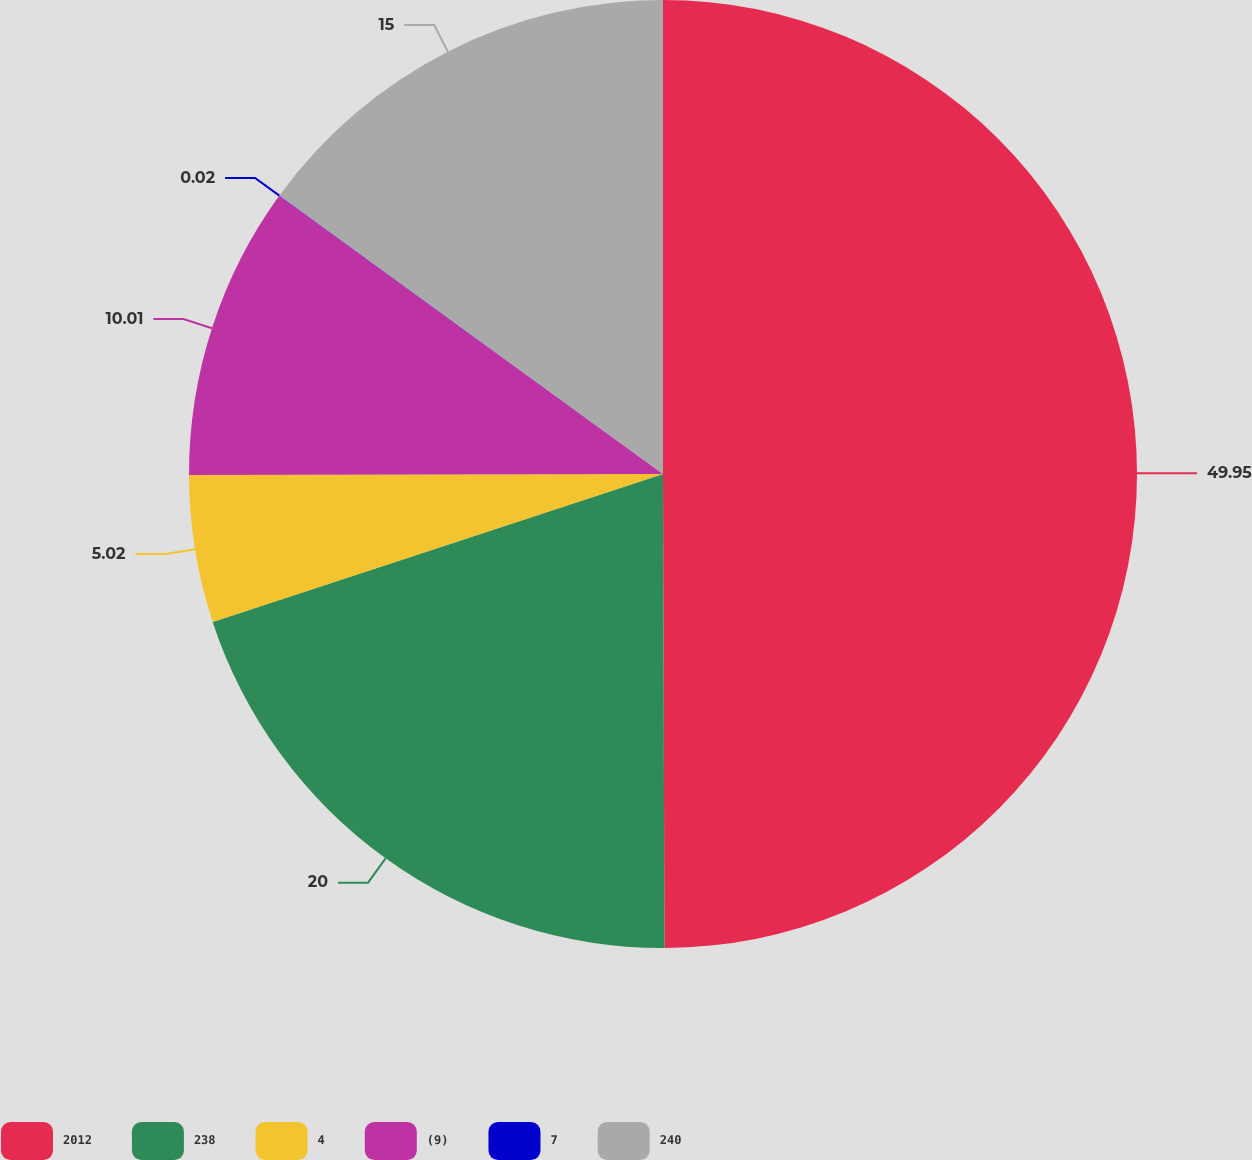Convert chart to OTSL. <chart><loc_0><loc_0><loc_500><loc_500><pie_chart><fcel>2012<fcel>238<fcel>4<fcel>(9)<fcel>7<fcel>240<nl><fcel>49.95%<fcel>20.0%<fcel>5.02%<fcel>10.01%<fcel>0.02%<fcel>15.0%<nl></chart> 